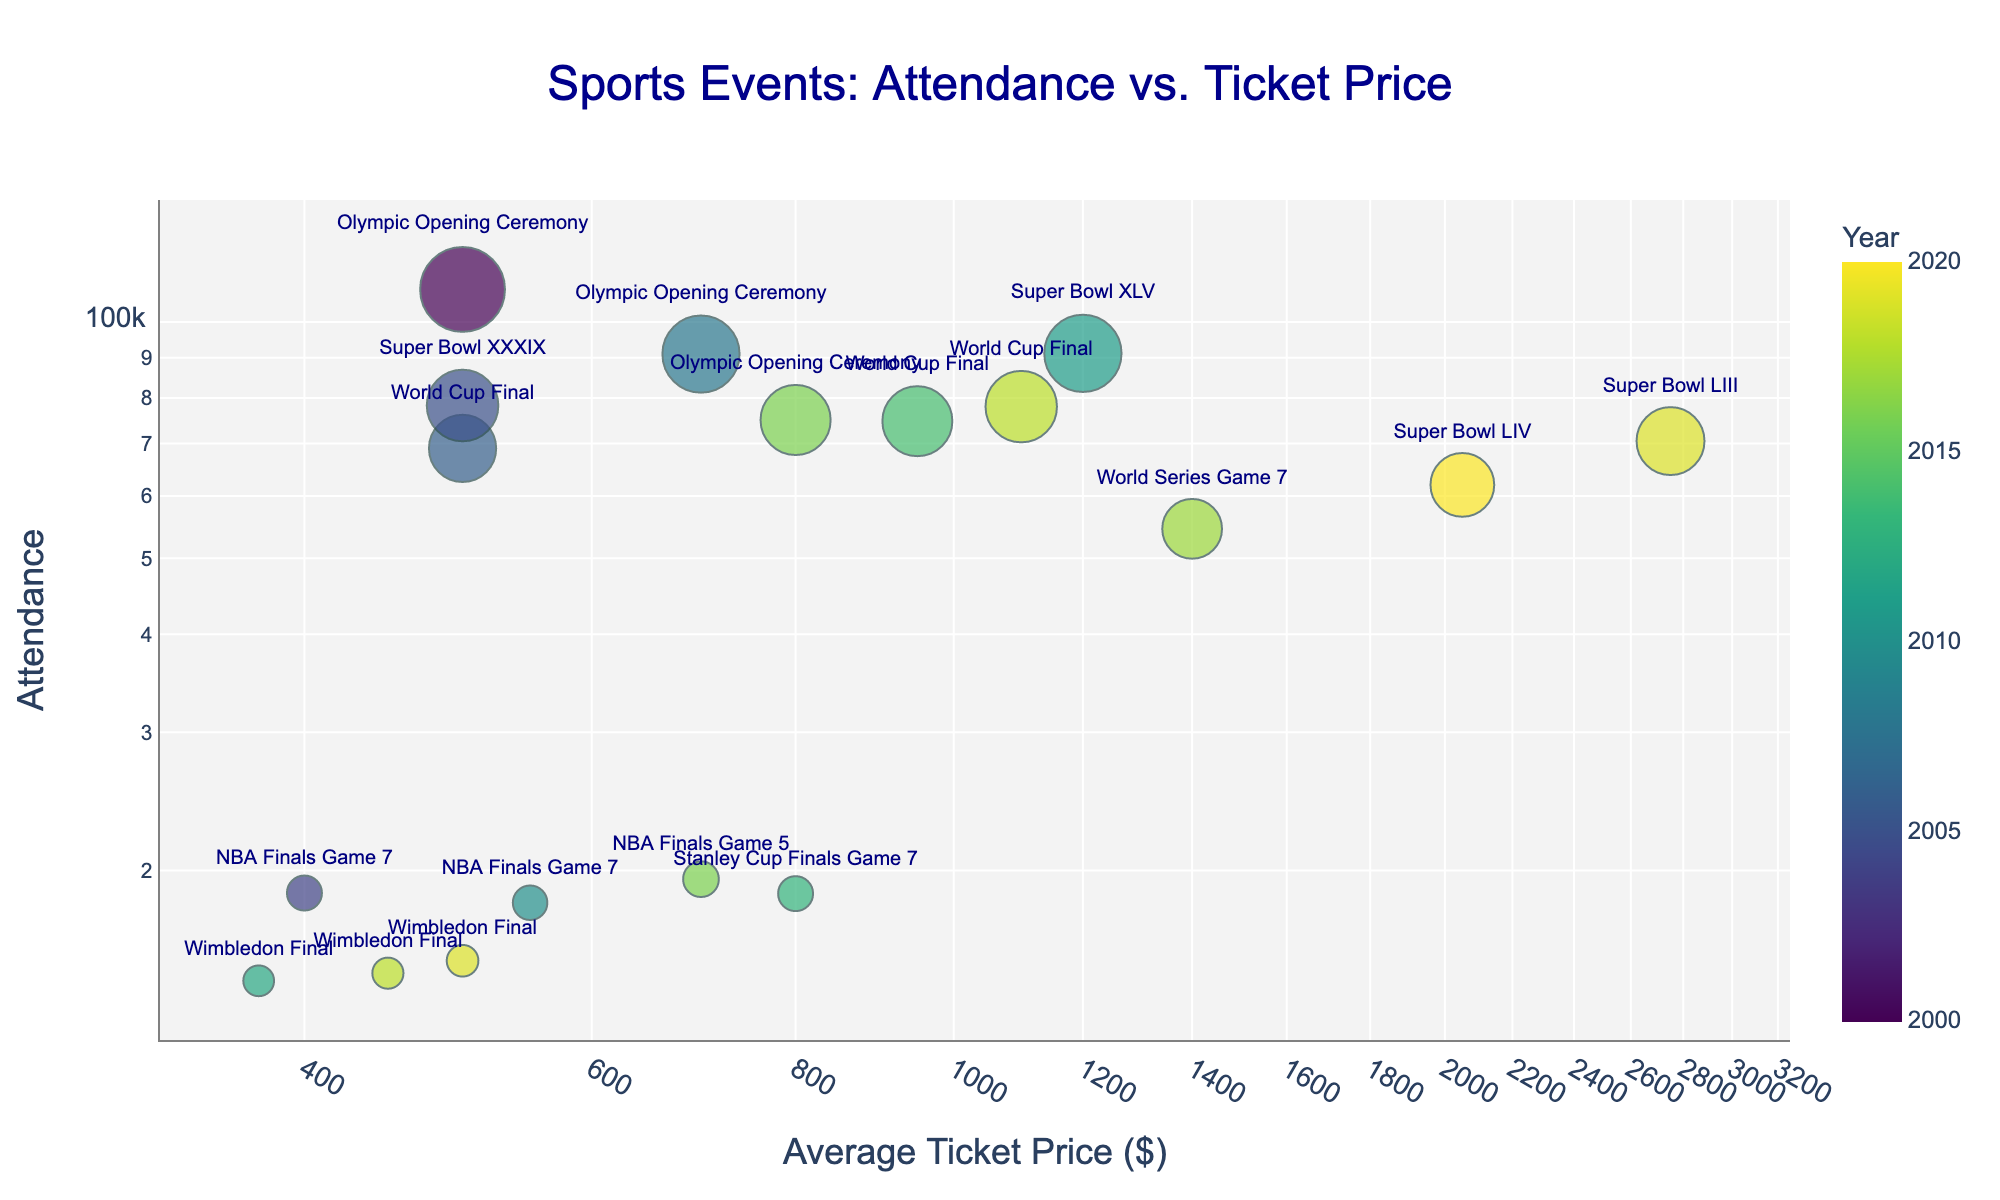How many events took place in 2019? Look for data points labeled with the year 2019 and count them. The events in 2019 are Super Bowl LIII and Wimbledon Final.
Answer: 2 Which event had the highest average ticket price? Check the x-axis for the data point farthest to the right. The farthest right data point corresponds to Super Bowl LIII in 2019 with an average ticket price of $2750.
Answer: Super Bowl LIII Which year had the most diverse range of events based on the plot colors? Identify the year with the most number of unique colors (data points). The year with the broadest range of event colors in this chart is 2016, featuring NBA Finals Game 5 and Olympic Opening Ceremony.
Answer: 2016 What event had the lowest attendance among the plotted data? Check the y-axis for the data point closest to the bottom. The event with the lowest attendance is Wimbledon Final in 2012 with 14,473 attendees.
Answer: Wimbledon Final 2012 On the plot, is there a clear pattern between ticket price and event attendance? Look at the scatter plot trend, noting if higher ticket prices generally relate to higher or lower attendances. There is no clear pattern or direct correlation between ticket prices and attendance across the events.
Answer: No clear pattern Which sport event had the largest attendance for the ticket prices below $1000? Filter data points where the x-axis value is less than $1000 and locate the highest y-axis value. The World Cup Final 2014 has the highest attendance of 74,738 for ticket prices below $1000.
Answer: World Cup Final 2014 